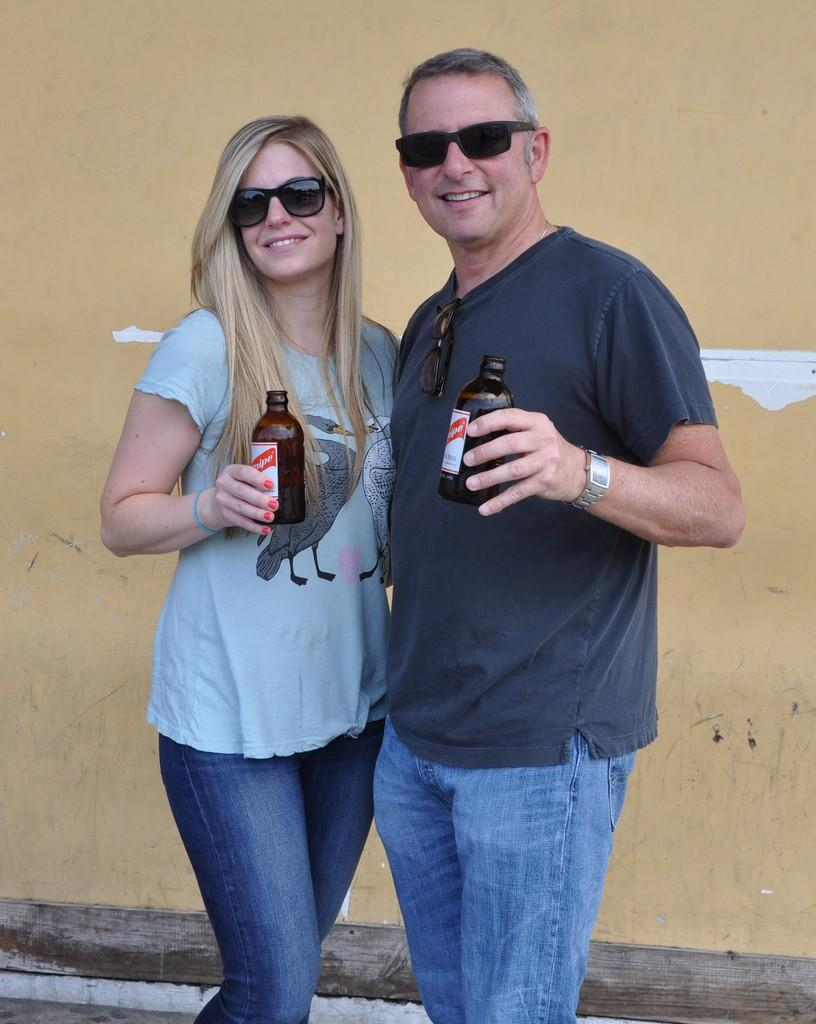How many people are in the image? There are two people in the image, a man and a woman. What are the man and woman wearing on their faces? Both the man and woman are wearing goggles. What are the man and woman doing in the image? They are standing together and holding bottles in their hands. What can be seen in the background of the image? There is a wall in the background of the image. Can you see any ants crawling on the man's goggles in the image? There are no ants visible in the image, as it features a man and a woman wearing goggles and holding bottles. How do the giants in the image interact with the wall in the background? There are no giants present in the image; it features a man and a woman standing together with goggles and bottles. 